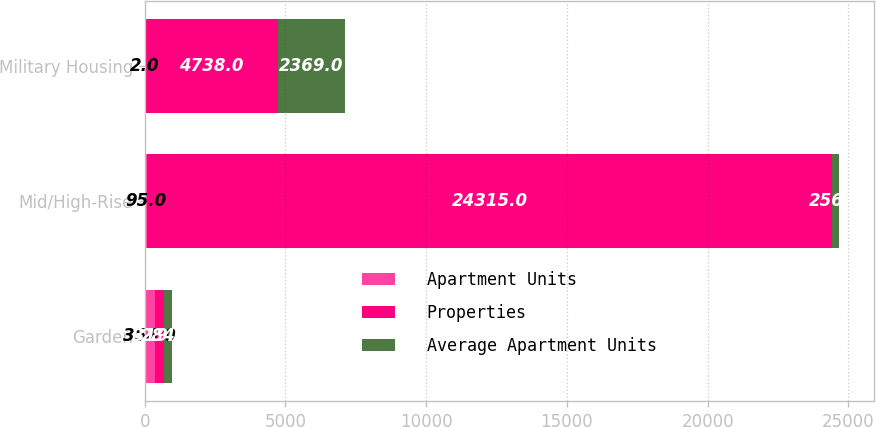Convert chart to OTSL. <chart><loc_0><loc_0><loc_500><loc_500><stacked_bar_chart><ecel><fcel>Garden<fcel>Mid/High-Rise<fcel>Military Housing<nl><fcel>Apartment Units<fcel>354<fcel>95<fcel>2<nl><fcel>Properties<fcel>319<fcel>24315<fcel>4738<nl><fcel>Average Apartment Units<fcel>284<fcel>256<fcel>2369<nl></chart> 